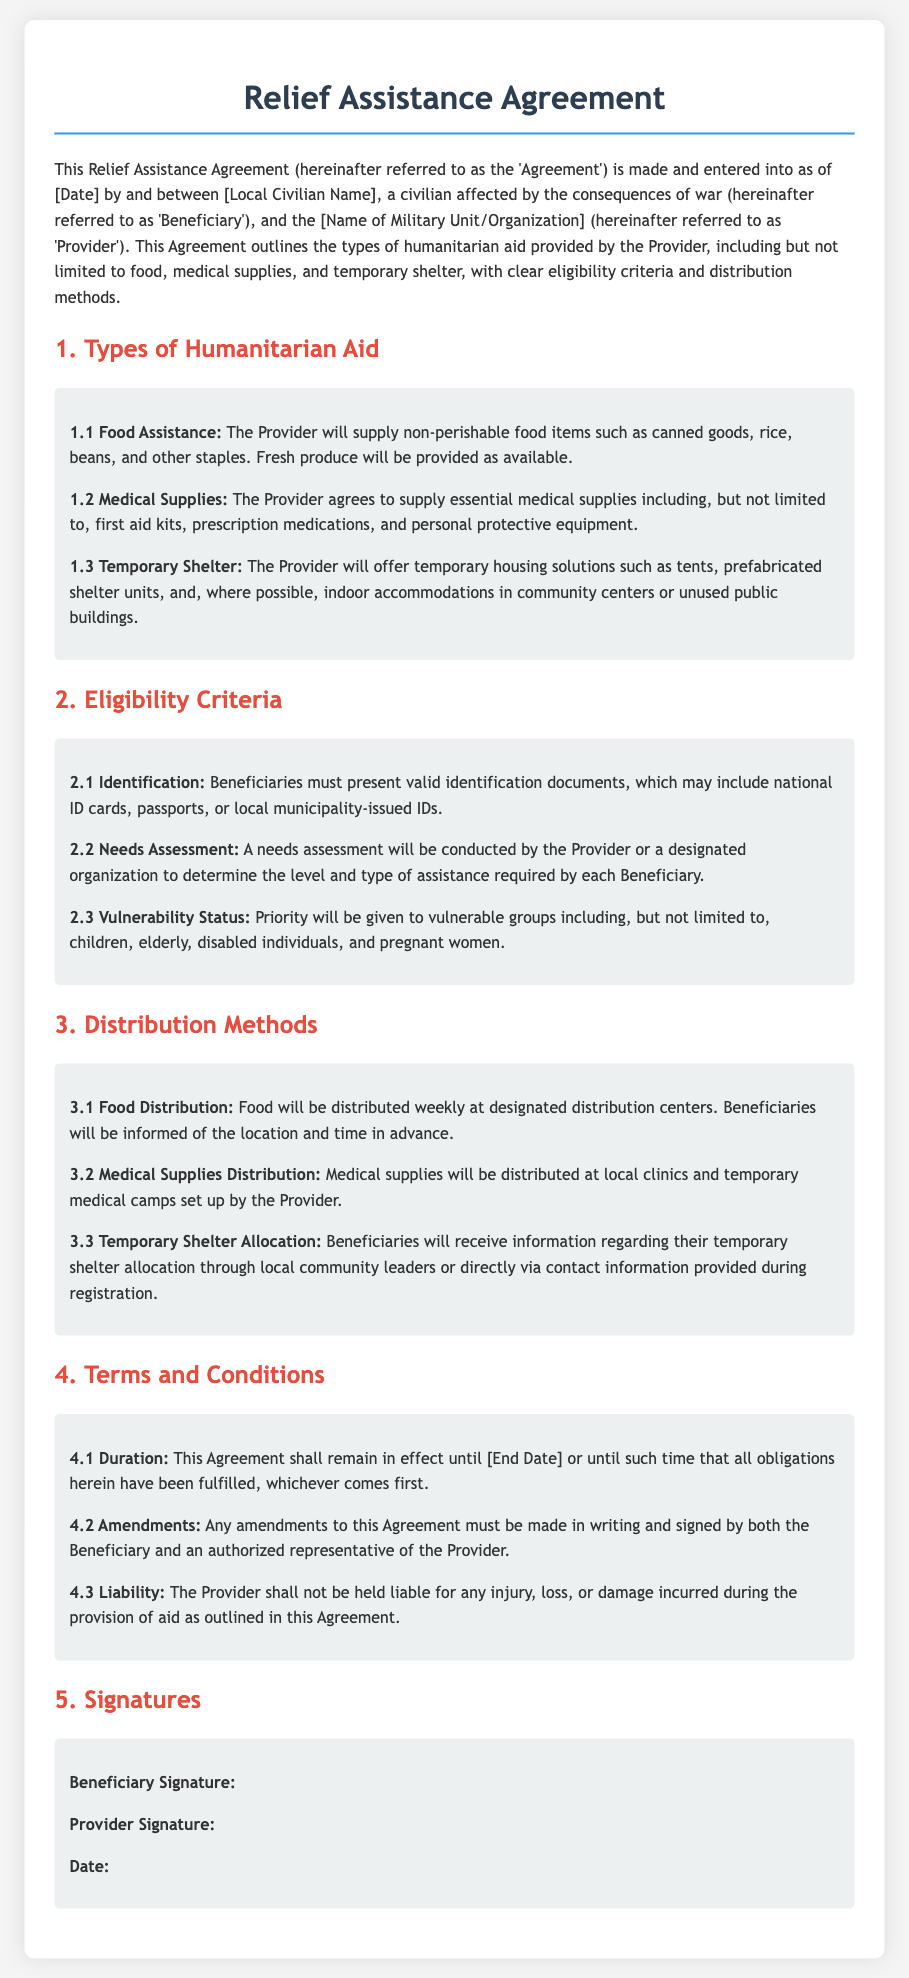What types of humanitarian aid are provided? The types of humanitarian aid are listed in Section 1, which includes food assistance, medical supplies, and temporary shelter.
Answer: Food assistance, medical supplies, and temporary shelter Who is referred to as the Beneficiary in the agreement? The Beneficiary is defined at the beginning of the document as a civilian affected by war, specifically identified by the local civilian name.
Answer: Local Civilian Name What must beneficiaries present to be eligible for assistance? Eligibility criteria in Section 2 outlines that beneficiaries must present valid identification documents.
Answer: Valid identification documents Which group is prioritized according to the vulnerability status? Section 2.3 mentions that priority is given to vulnerable groups, specifically children, elderly, disabled individuals, and pregnant women.
Answer: Children, elderly, disabled individuals, and pregnant women How often will food be distributed? The distribution methods in Section 3.1 specify that food will be distributed weekly at designated centers.
Answer: Weekly What is the effective duration of this agreement? Section 4.1 states that the agreement remains in effect until the end date or until obligations are fulfilled, whichever comes first.
Answer: Until the end date or until obligations are fulfilled Where will medical supplies be distributed? Section 3.2 indicates that medical supplies will be distributed at local clinics and temporary medical camps.
Answer: Local clinics and temporary medical camps What must happen for amendments to be made to the agreement? Section 4.2 specifies that any amendments must be in writing and signed by both parties.
Answer: Must be in writing and signed by both parties 